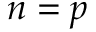<formula> <loc_0><loc_0><loc_500><loc_500>n = p</formula> 